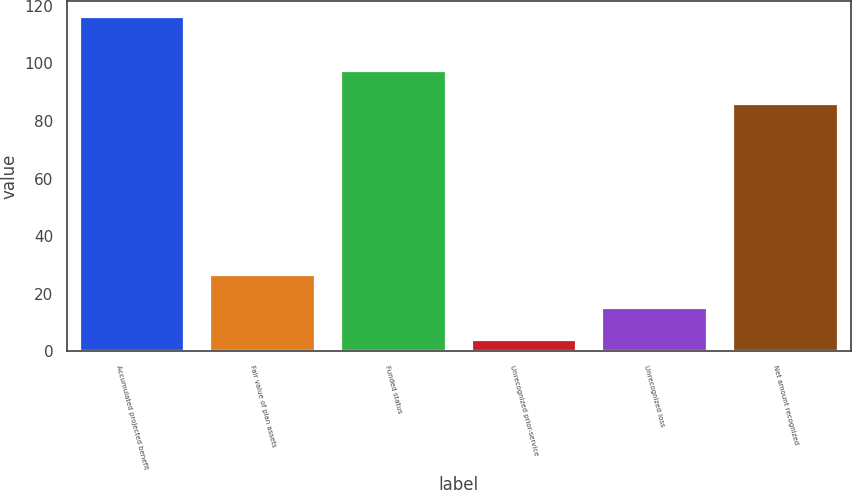Convert chart. <chart><loc_0><loc_0><loc_500><loc_500><bar_chart><fcel>Accumulated projected benefit<fcel>Fair value of plan assets<fcel>Funded status<fcel>Unrecognized prior-service<fcel>Unrecognized loss<fcel>Net amount recognized<nl><fcel>116<fcel>26.4<fcel>97.2<fcel>4<fcel>15.2<fcel>86<nl></chart> 